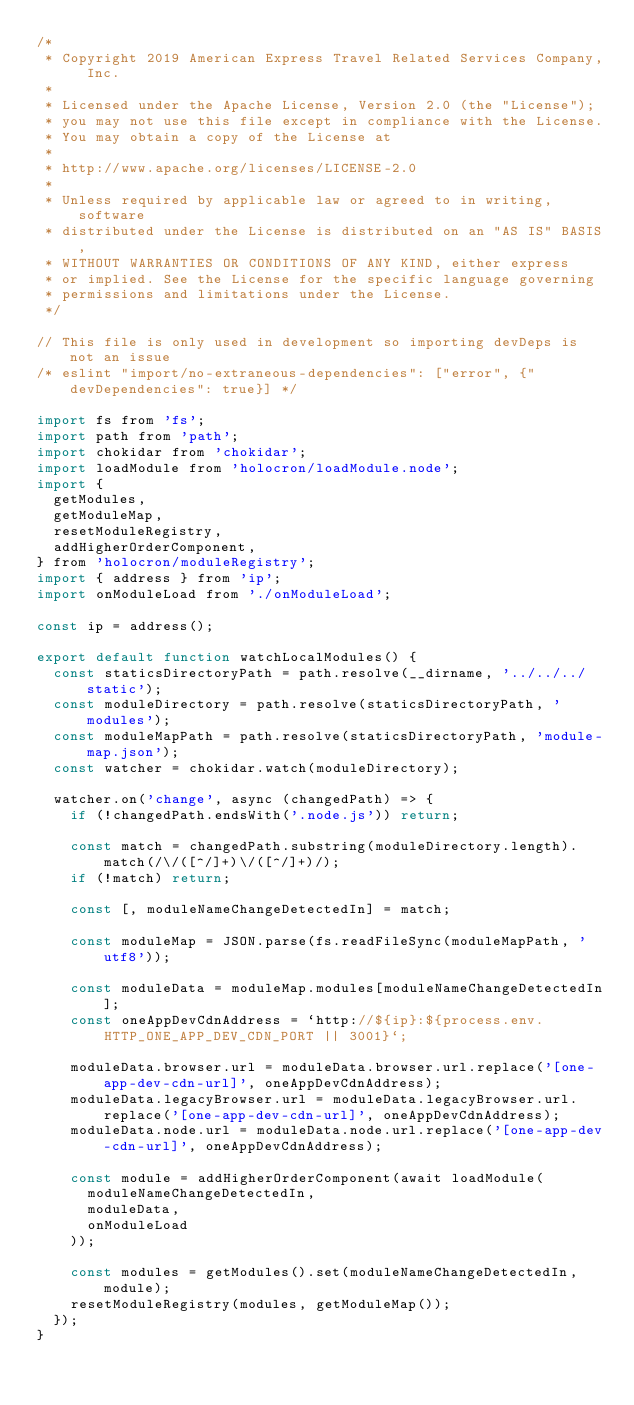<code> <loc_0><loc_0><loc_500><loc_500><_JavaScript_>/*
 * Copyright 2019 American Express Travel Related Services Company, Inc.
 *
 * Licensed under the Apache License, Version 2.0 (the "License");
 * you may not use this file except in compliance with the License.
 * You may obtain a copy of the License at
 *
 * http://www.apache.org/licenses/LICENSE-2.0
 *
 * Unless required by applicable law or agreed to in writing, software
 * distributed under the License is distributed on an "AS IS" BASIS,
 * WITHOUT WARRANTIES OR CONDITIONS OF ANY KIND, either express
 * or implied. See the License for the specific language governing
 * permissions and limitations under the License.
 */

// This file is only used in development so importing devDeps is not an issue
/* eslint "import/no-extraneous-dependencies": ["error", {"devDependencies": true}] */

import fs from 'fs';
import path from 'path';
import chokidar from 'chokidar';
import loadModule from 'holocron/loadModule.node';
import {
  getModules,
  getModuleMap,
  resetModuleRegistry,
  addHigherOrderComponent,
} from 'holocron/moduleRegistry';
import { address } from 'ip';
import onModuleLoad from './onModuleLoad';

const ip = address();

export default function watchLocalModules() {
  const staticsDirectoryPath = path.resolve(__dirname, '../../../static');
  const moduleDirectory = path.resolve(staticsDirectoryPath, 'modules');
  const moduleMapPath = path.resolve(staticsDirectoryPath, 'module-map.json');
  const watcher = chokidar.watch(moduleDirectory);

  watcher.on('change', async (changedPath) => {
    if (!changedPath.endsWith('.node.js')) return;

    const match = changedPath.substring(moduleDirectory.length).match(/\/([^/]+)\/([^/]+)/);
    if (!match) return;

    const [, moduleNameChangeDetectedIn] = match;

    const moduleMap = JSON.parse(fs.readFileSync(moduleMapPath, 'utf8'));

    const moduleData = moduleMap.modules[moduleNameChangeDetectedIn];
    const oneAppDevCdnAddress = `http://${ip}:${process.env.HTTP_ONE_APP_DEV_CDN_PORT || 3001}`;

    moduleData.browser.url = moduleData.browser.url.replace('[one-app-dev-cdn-url]', oneAppDevCdnAddress);
    moduleData.legacyBrowser.url = moduleData.legacyBrowser.url.replace('[one-app-dev-cdn-url]', oneAppDevCdnAddress);
    moduleData.node.url = moduleData.node.url.replace('[one-app-dev-cdn-url]', oneAppDevCdnAddress);

    const module = addHigherOrderComponent(await loadModule(
      moduleNameChangeDetectedIn,
      moduleData,
      onModuleLoad
    ));

    const modules = getModules().set(moduleNameChangeDetectedIn, module);
    resetModuleRegistry(modules, getModuleMap());
  });
}
</code> 